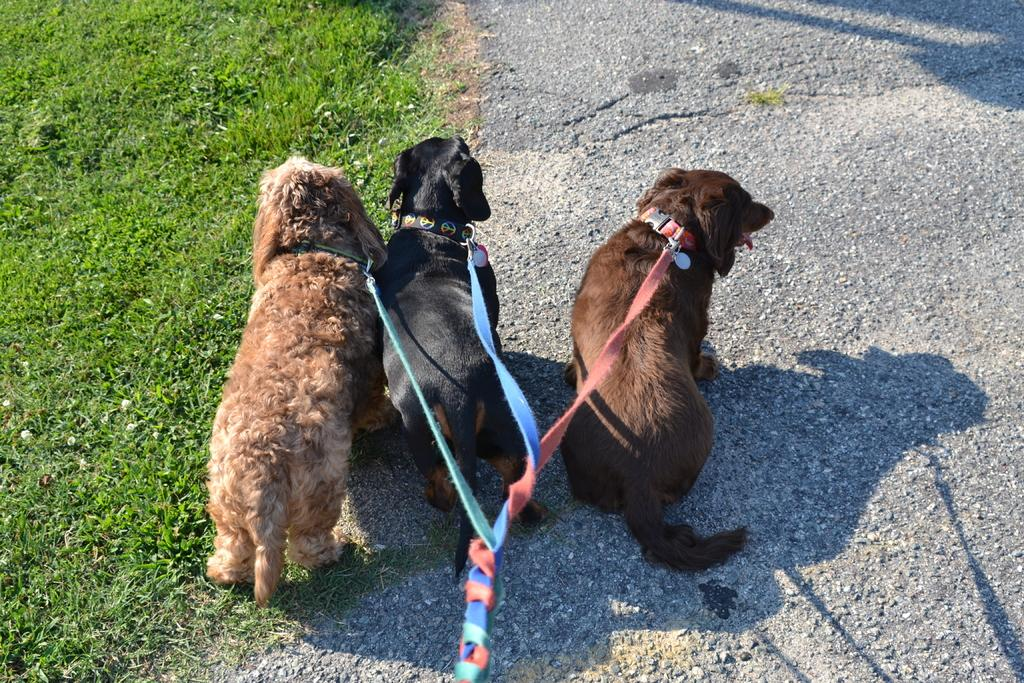What animals are present in the image? There are dogs in the image. How are the dogs secured in the image? The dogs are tied with belts. What type of terrain is visible in the image? There is grass visible in the image. What type of baseball equipment can be seen in the image? There is no baseball equipment present in the image; it features dogs tied with belts on grass. 